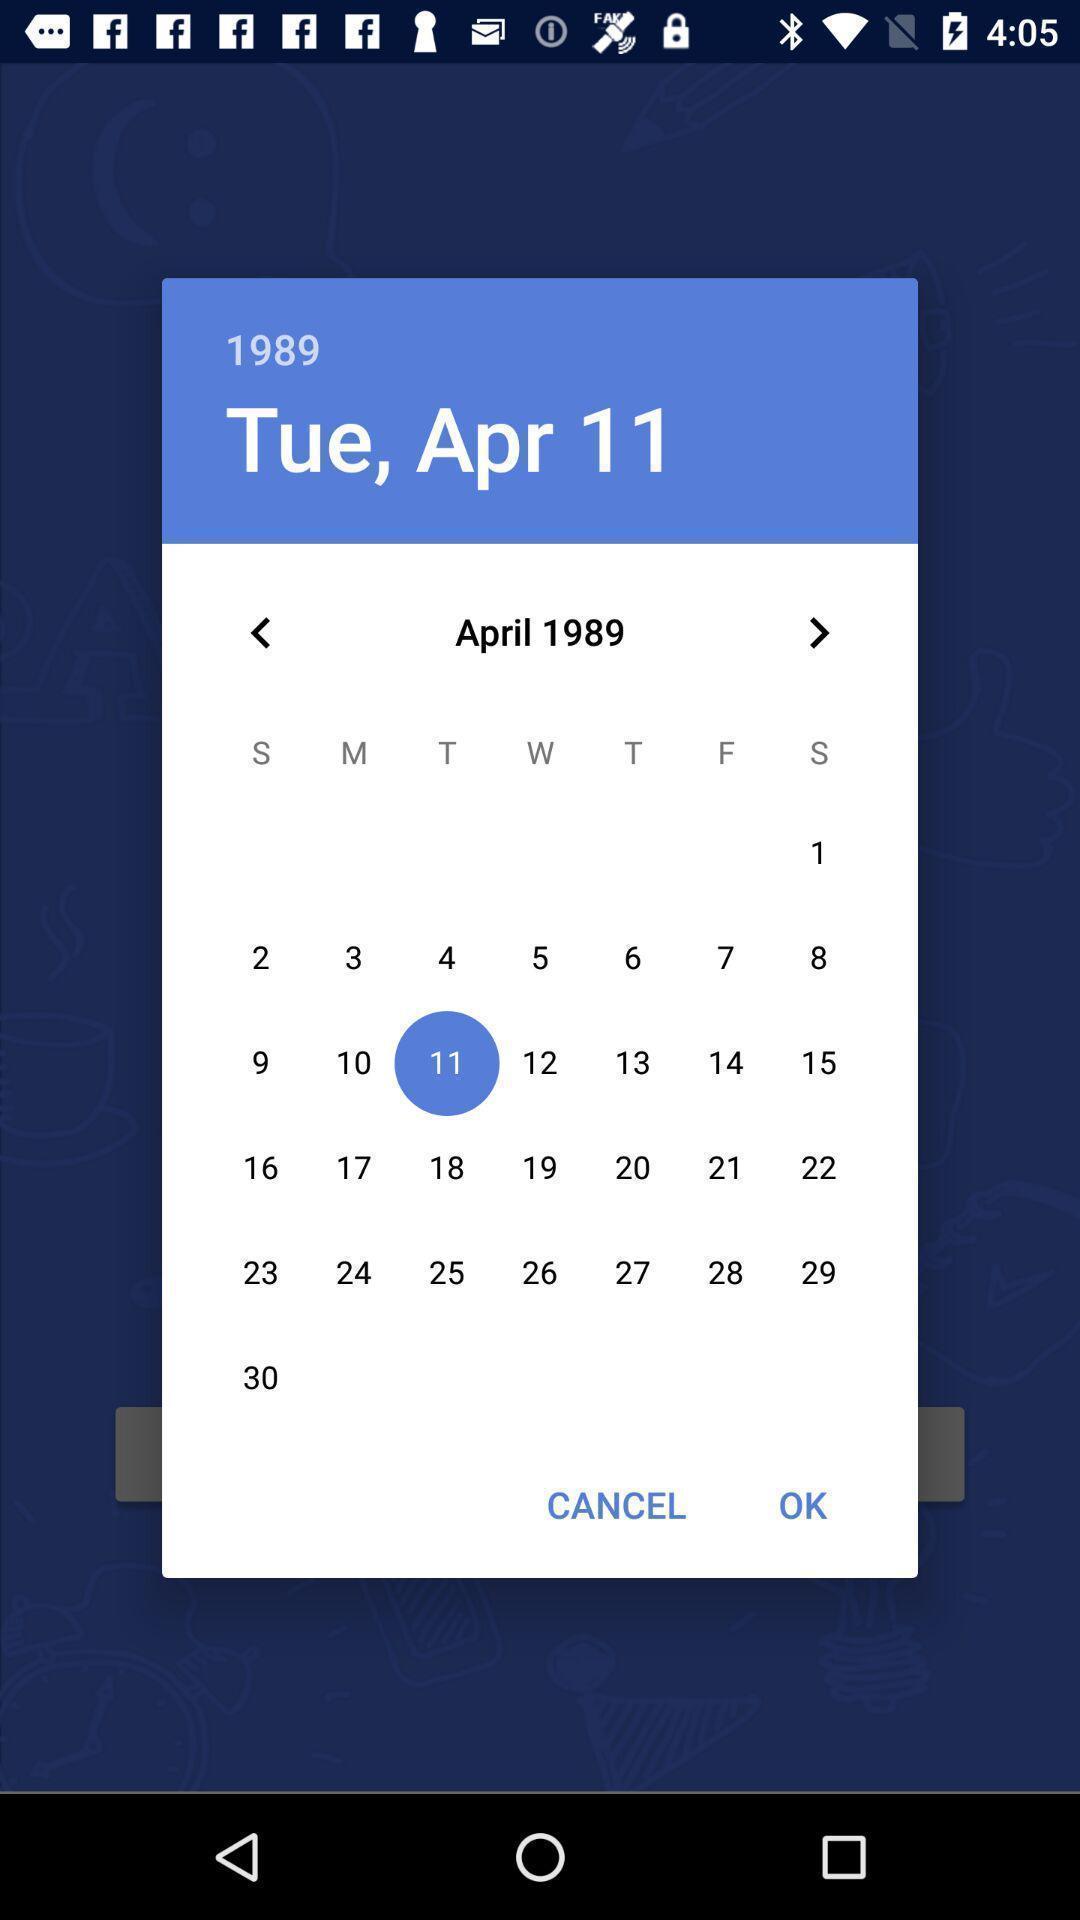Please provide a description for this image. Popup showing calendar. 